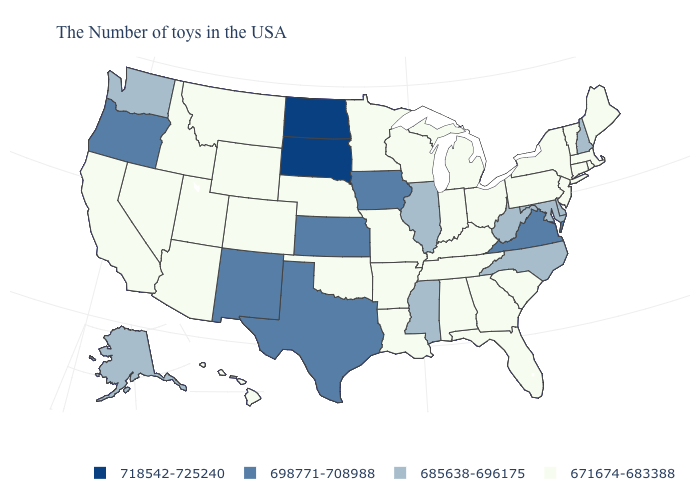Does Massachusetts have the lowest value in the Northeast?
Answer briefly. Yes. What is the value of Washington?
Short answer required. 685638-696175. Among the states that border South Carolina , does Georgia have the highest value?
Be succinct. No. Name the states that have a value in the range 685638-696175?
Short answer required. New Hampshire, Delaware, Maryland, North Carolina, West Virginia, Illinois, Mississippi, Washington, Alaska. What is the value of Montana?
Give a very brief answer. 671674-683388. Is the legend a continuous bar?
Keep it brief. No. Name the states that have a value in the range 685638-696175?
Short answer required. New Hampshire, Delaware, Maryland, North Carolina, West Virginia, Illinois, Mississippi, Washington, Alaska. Does Illinois have the highest value in the USA?
Write a very short answer. No. Does the first symbol in the legend represent the smallest category?
Concise answer only. No. Name the states that have a value in the range 718542-725240?
Write a very short answer. South Dakota, North Dakota. Which states have the highest value in the USA?
Write a very short answer. South Dakota, North Dakota. What is the value of New York?
Give a very brief answer. 671674-683388. Name the states that have a value in the range 685638-696175?
Write a very short answer. New Hampshire, Delaware, Maryland, North Carolina, West Virginia, Illinois, Mississippi, Washington, Alaska. What is the value of Kansas?
Concise answer only. 698771-708988. 